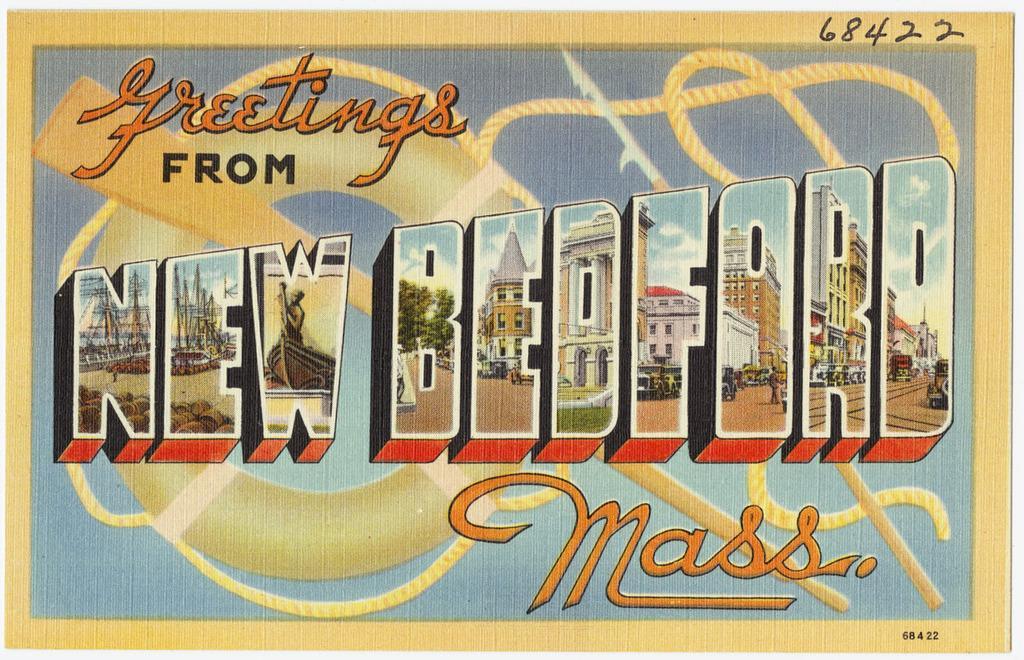Please provide a concise description of this image. In the picture we can see a cartoon image of a card and on it we can see written as greetings from new bedford. 